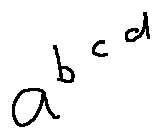Convert formula to latex. <formula><loc_0><loc_0><loc_500><loc_500>a ^ { b ^ { c ^ { d } } }</formula> 